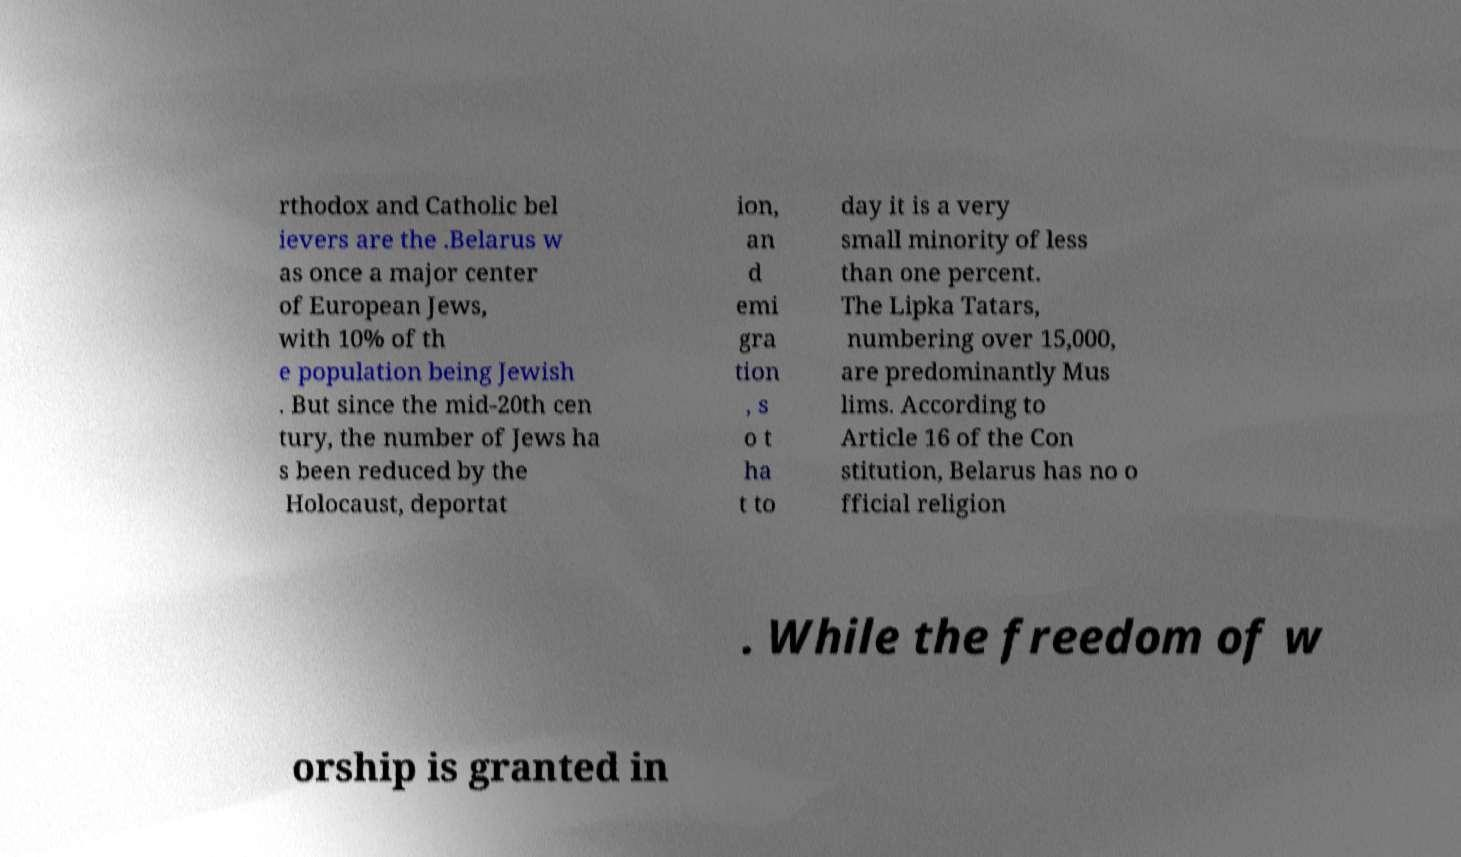Can you read and provide the text displayed in the image?This photo seems to have some interesting text. Can you extract and type it out for me? rthodox and Catholic bel ievers are the .Belarus w as once a major center of European Jews, with 10% of th e population being Jewish . But since the mid-20th cen tury, the number of Jews ha s been reduced by the Holocaust, deportat ion, an d emi gra tion , s o t ha t to day it is a very small minority of less than one percent. The Lipka Tatars, numbering over 15,000, are predominantly Mus lims. According to Article 16 of the Con stitution, Belarus has no o fficial religion . While the freedom of w orship is granted in 